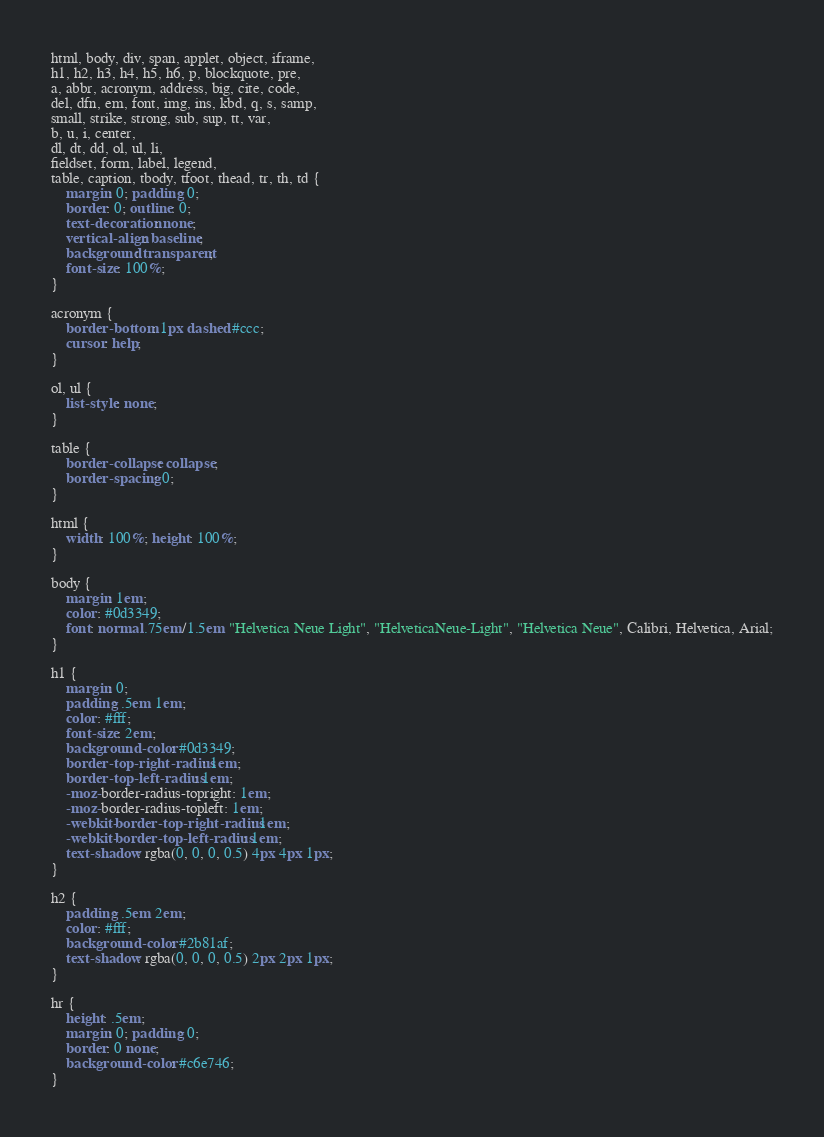<code> <loc_0><loc_0><loc_500><loc_500><_CSS_>html, body, div, span, applet, object, iframe,
h1, h2, h3, h4, h5, h6, p, blockquote, pre,
a, abbr, acronym, address, big, cite, code,
del, dfn, em, font, img, ins, kbd, q, s, samp,
small, strike, strong, sub, sup, tt, var,
b, u, i, center,
dl, dt, dd, ol, ul, li,
fieldset, form, label, legend,
table, caption, tbody, tfoot, thead, tr, th, td {
	margin: 0; padding: 0;
	border: 0; outline: 0;
    text-decoration: none;
	vertical-align: baseline;
	background: transparent;
	font-size: 100%;
}

acronym {
    border-bottom: 1px dashed #ccc;
    cursor: help;
}

ol, ul {
	list-style: none;
}

table {
	border-collapse: collapse;
	border-spacing: 0;
}

html {
    width: 100%; height: 100%;
}

body {
    margin: 1em;
	color: #0d3349;
    font: normal .75em/1.5em "Helvetica Neue Light", "HelveticaNeue-Light", "Helvetica Neue", Calibri, Helvetica, Arial;
}

h1 {
	margin: 0;
	padding: .5em 1em;
	color: #fff;
    font-size: 2em;
	background-color: #0d3349;
	border-top-right-radius: 1em;
	border-top-left-radius: 1em;
	-moz-border-radius-topright: 1em;
	-moz-border-radius-topleft: 1em;
	-webkit-border-top-right-radius: 1em;
	-webkit-border-top-left-radius: 1em;
	text-shadow: rgba(0, 0, 0, 0.5) 4px 4px 1px;
}

h2 {
	padding: .5em 2em;
    color: #fff;
    background-color: #2b81af;
	text-shadow: rgba(0, 0, 0, 0.5) 2px 2px 1px;
}

hr {
    height: .5em;
    margin: 0; padding: 0;
    border: 0 none;
    background-color: #c6e746;
}
</code> 